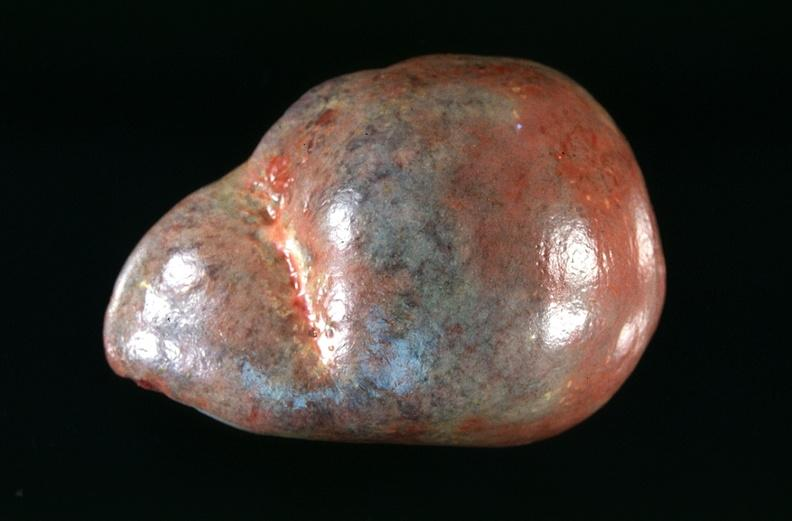does this image show spleen, congestion in a patient with disseminated intravascular coagulation and alpha-1 antitrypsin deficiency?
Answer the question using a single word or phrase. Yes 